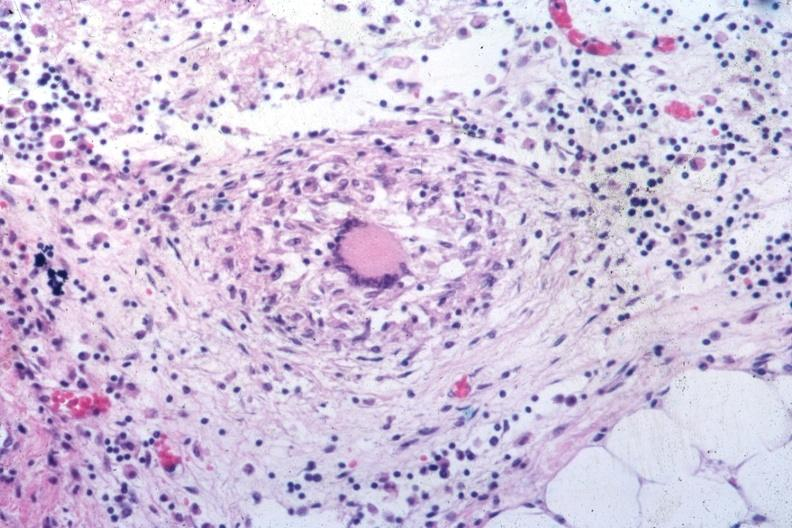s abdomen present?
Answer the question using a single word or phrase. Yes 